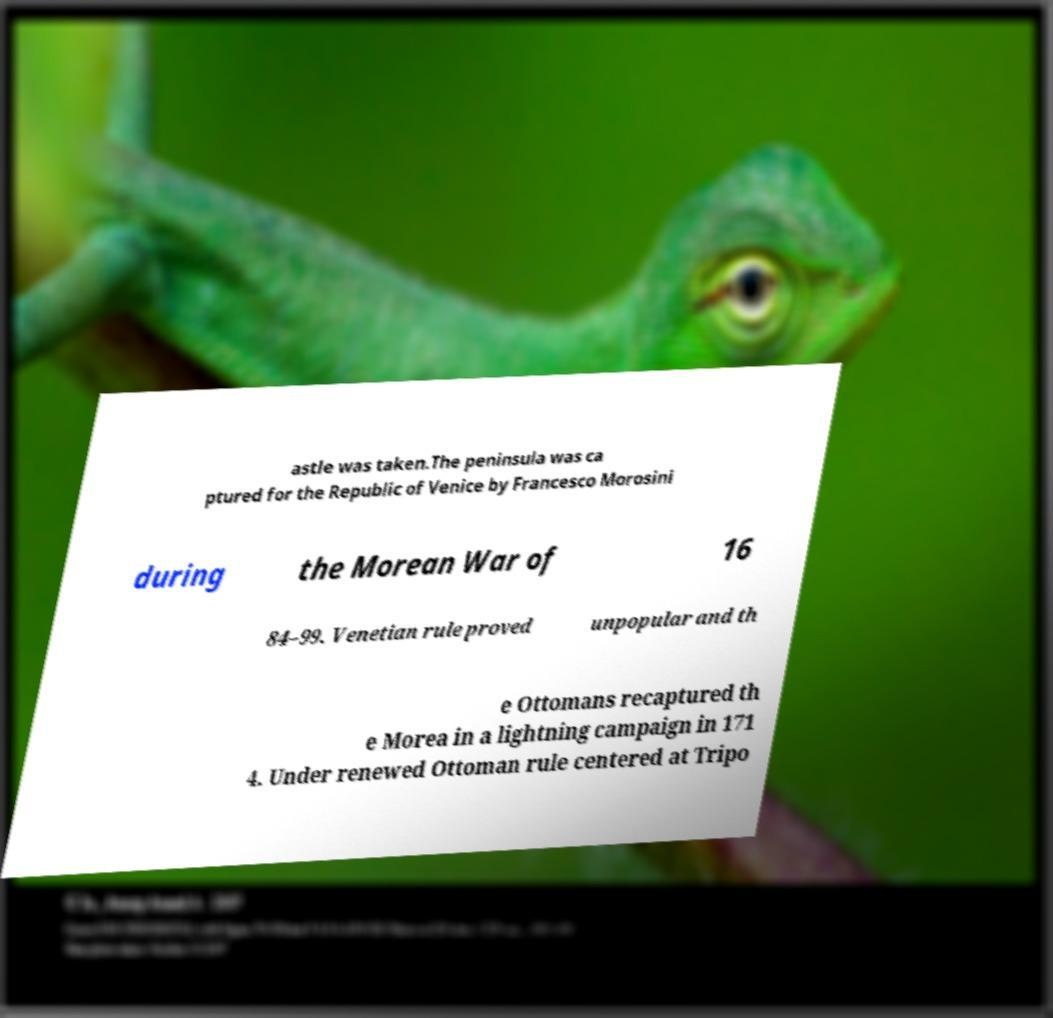Can you read and provide the text displayed in the image?This photo seems to have some interesting text. Can you extract and type it out for me? astle was taken.The peninsula was ca ptured for the Republic of Venice by Francesco Morosini during the Morean War of 16 84–99. Venetian rule proved unpopular and th e Ottomans recaptured th e Morea in a lightning campaign in 171 4. Under renewed Ottoman rule centered at Tripo 